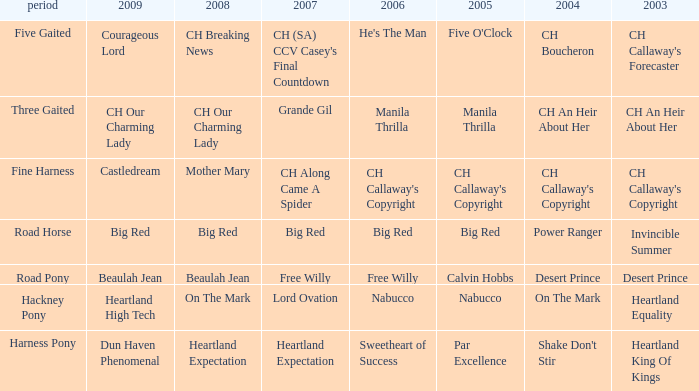What is the 2007 for the 2003 desert prince? Free Willy. 